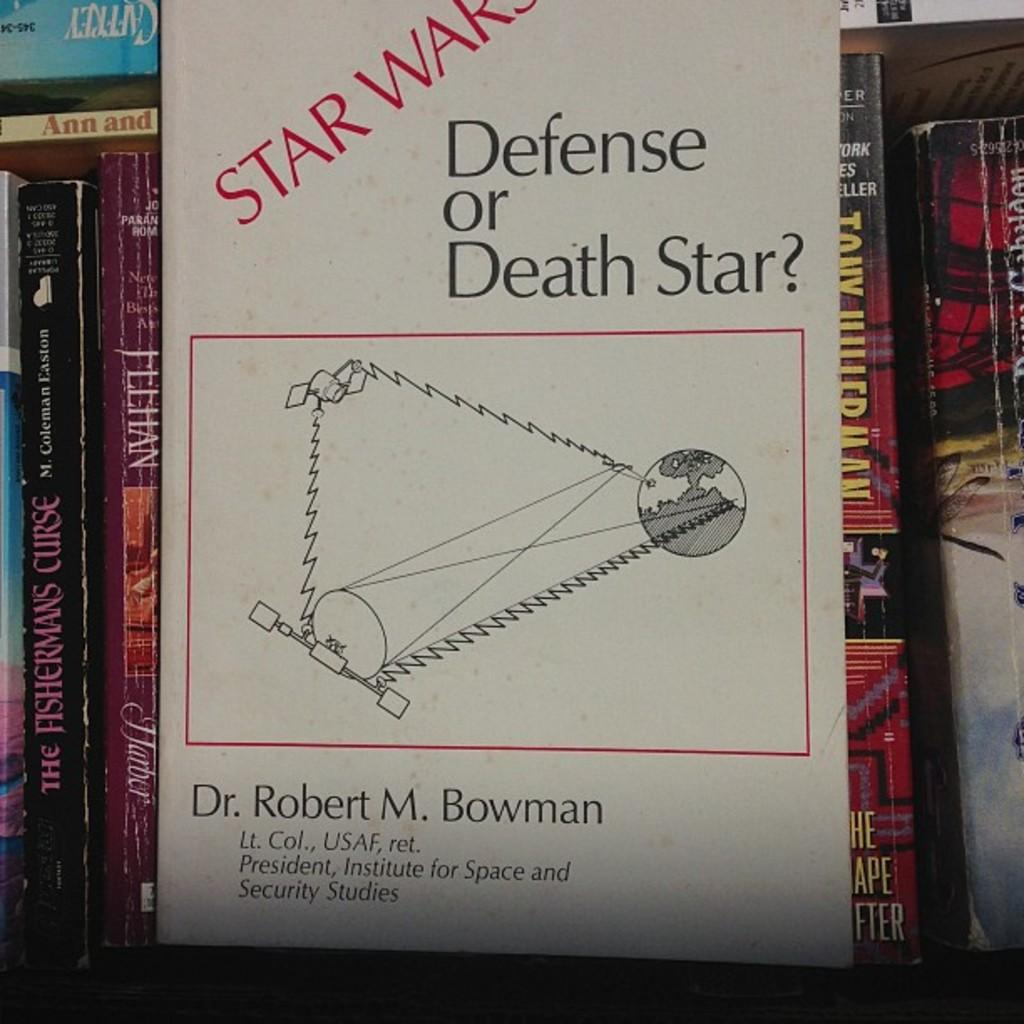<image>
Render a clear and concise summary of the photo. stack of books with one in front named star wars defense or death star 